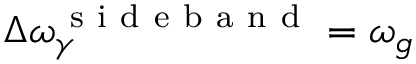Convert formula to latex. <formula><loc_0><loc_0><loc_500><loc_500>\Delta \omega _ { \gamma } ^ { s i d e b a n d } = \omega _ { g }</formula> 